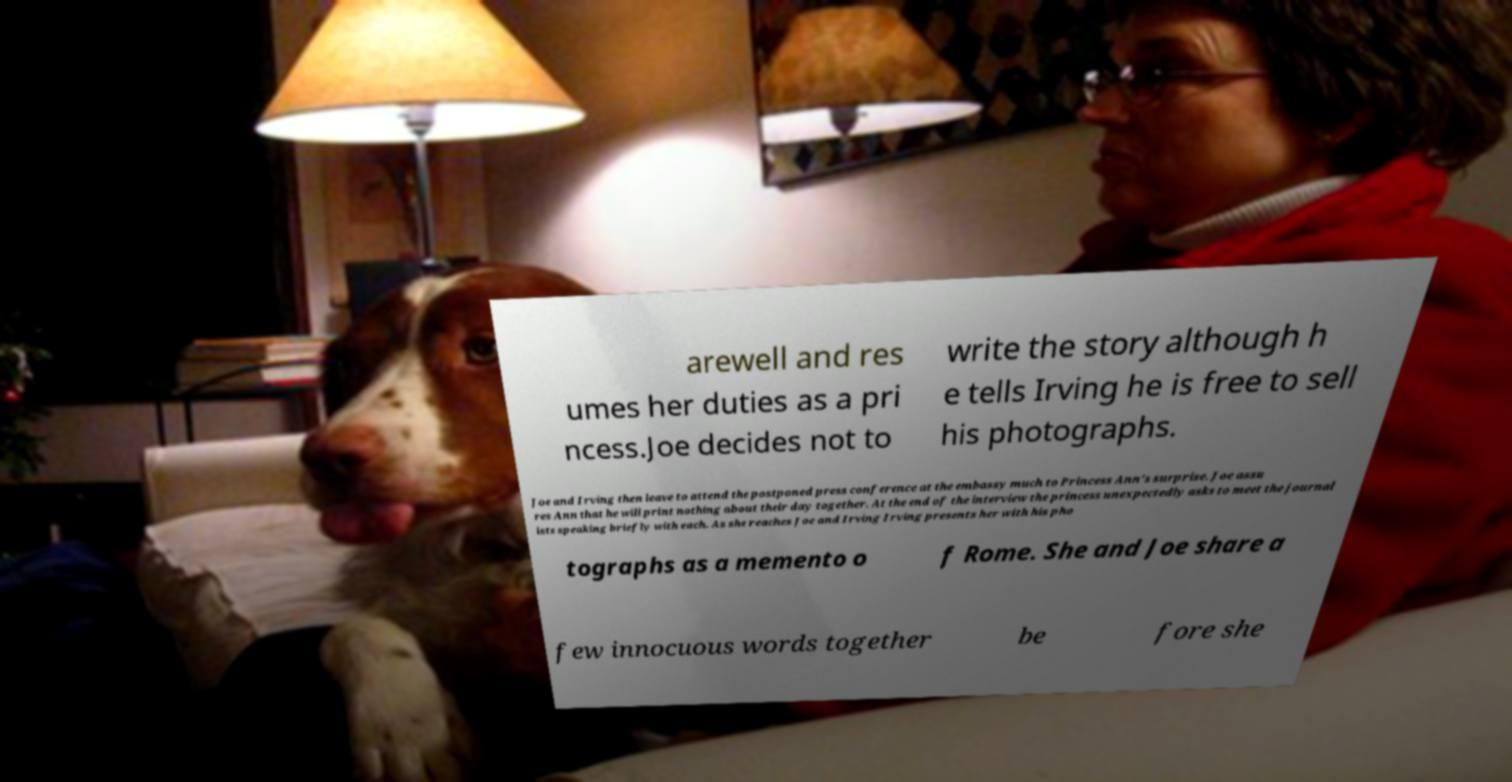Can you read and provide the text displayed in the image?This photo seems to have some interesting text. Can you extract and type it out for me? arewell and res umes her duties as a pri ncess.Joe decides not to write the story although h e tells Irving he is free to sell his photographs. Joe and Irving then leave to attend the postponed press conference at the embassy much to Princess Ann's surprise. Joe assu res Ann that he will print nothing about their day together. At the end of the interview the princess unexpectedly asks to meet the journal ists speaking briefly with each. As she reaches Joe and Irving Irving presents her with his pho tographs as a memento o f Rome. She and Joe share a few innocuous words together be fore she 